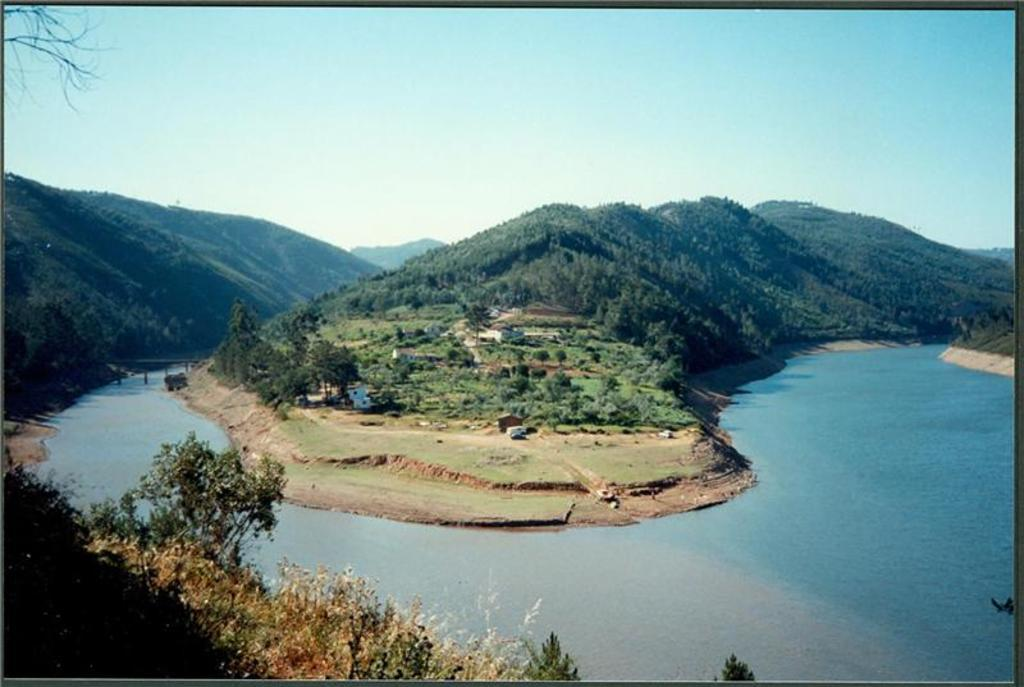What type of natural elements can be seen in the image? There are trees in the image. What man-made structure is present in the image? There is a bridge in the image. What color is the sky in the image? The sky is blue in the image. Where is the cent located in the image? There is no cent present in the image. What type of calendar is hanging on the trees in the image? There is no calendar present in the image. 